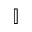<formula> <loc_0><loc_0><loc_500><loc_500>\mathbb { I }</formula> 